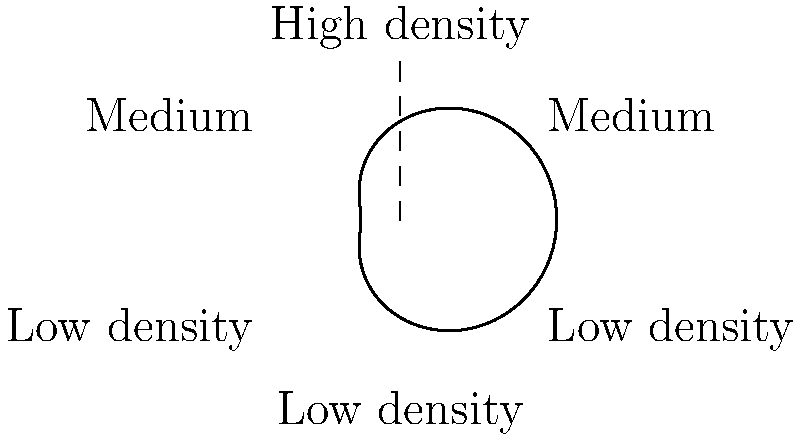The polar graph represents the tree density distribution across your circular land area. The distance from the center indicates higher tree density. Based on this distribution, which direction should you prioritize for new tree planting to maximize carbon sequestration potential? To answer this question, we need to analyze the polar graph and understand its representation of tree density:

1. The graph shows a circular land area divided into six sectors.
2. The distance from the center represents tree density - greater distance means higher density.
3. We can observe that:
   a. The northern sector (top) has the highest density.
   b. The southern sector (bottom) has the lowest density.
   c. The northeastern and northwestern sectors have medium density.
   d. The southeastern and southwestern sectors have low density.

4. To maximize carbon sequestration potential, we should prioritize planting in areas with the lowest current tree density.
5. This will allow for the greatest increase in overall tree coverage and carbon sequestration capacity.

6. Based on the graph, the southern sector (bottom) shows the lowest tree density.

Therefore, to maximize carbon sequestration potential, new tree planting should be prioritized in the southern direction.
Answer: Southern direction 